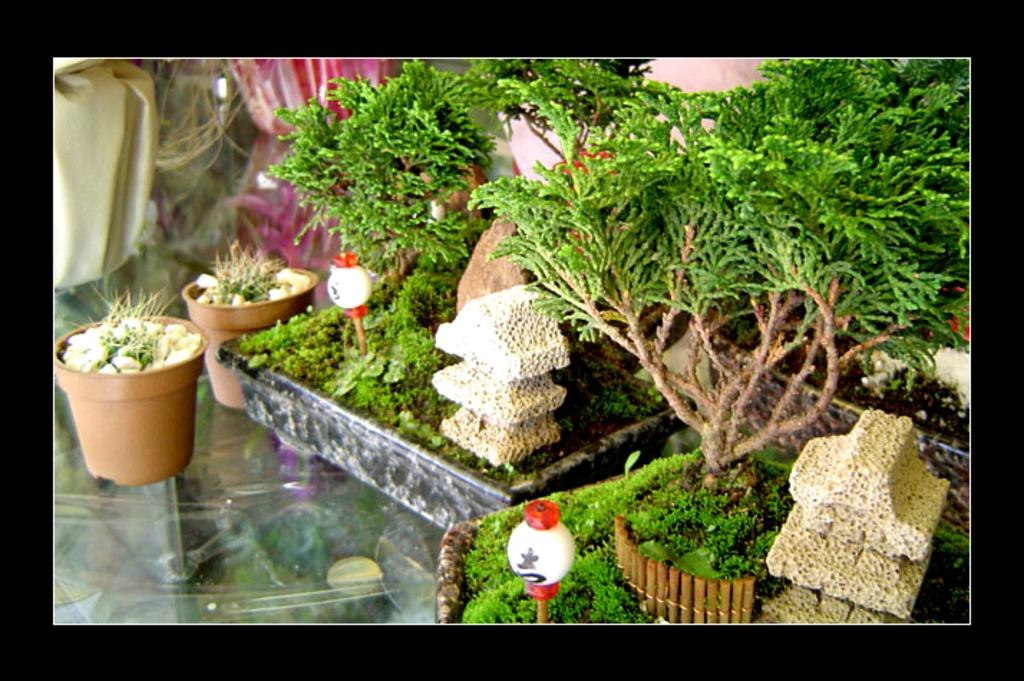What is the main object at the bottom of the image? There is a table at the bottom of the image. What is placed on the table? There are flower pots on the table. What is growing in the flower pots? There are plants in the flower pots. What else can be seen in the background of the image? There are other objects visible in the background of the image. How many clovers can be seen growing on the island in the image? There is no island or clover present in the image. 